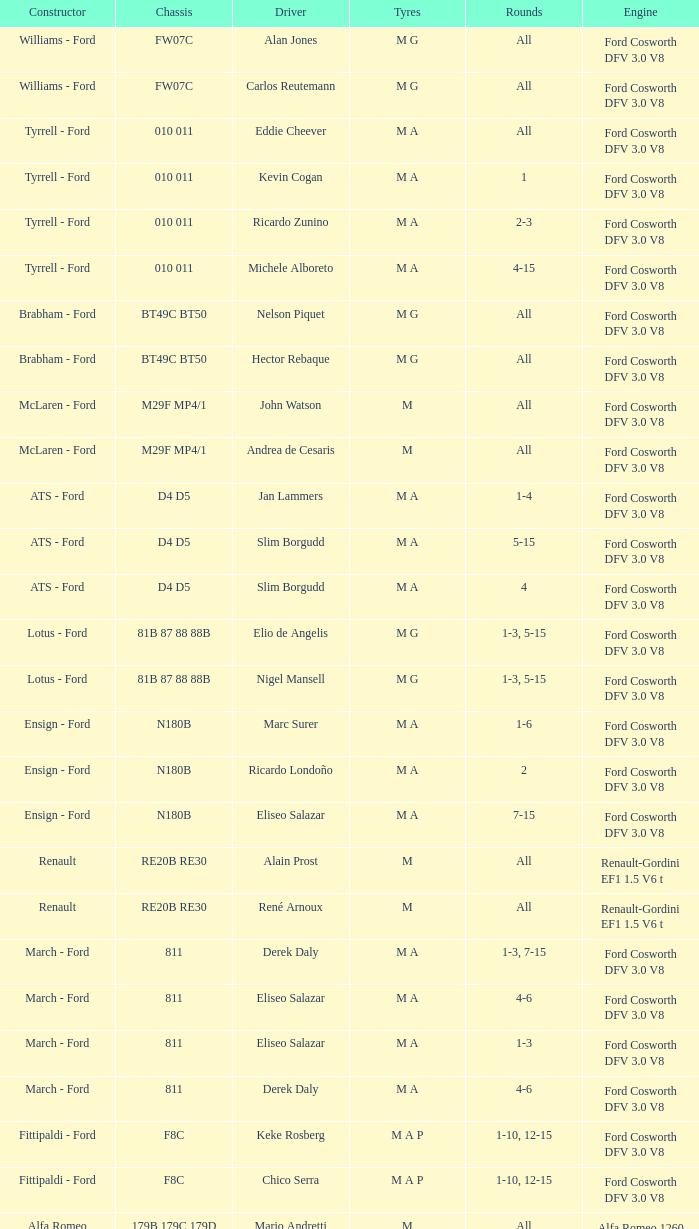Who constructed the car that Derek Warwick raced in with a TG181 chassis? Toleman - Hart. 